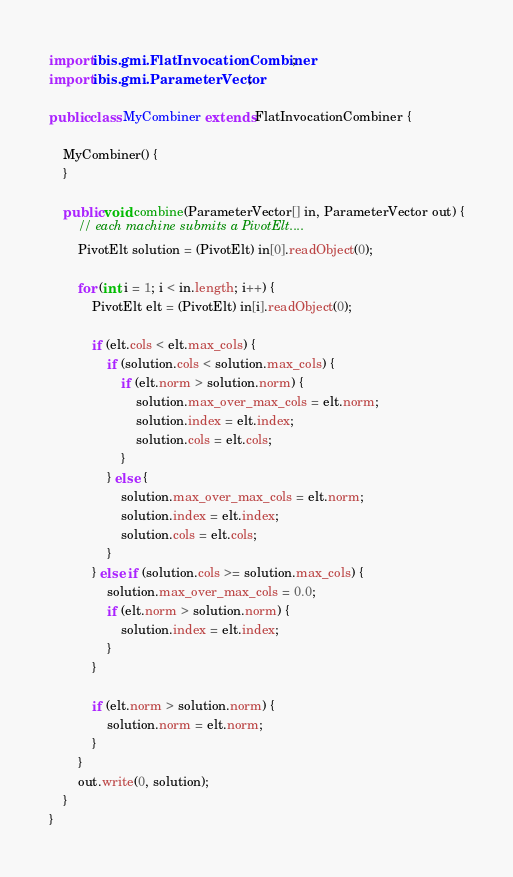Convert code to text. <code><loc_0><loc_0><loc_500><loc_500><_Java_>import ibis.gmi.FlatInvocationCombiner;
import ibis.gmi.ParameterVector;

public class MyCombiner extends FlatInvocationCombiner {

    MyCombiner() {
    }

    public void combine(ParameterVector[] in, ParameterVector out) {
        // each machine submits a PivotElt....
        PivotElt solution = (PivotElt) in[0].readObject(0);

        for (int i = 1; i < in.length; i++) {
            PivotElt elt = (PivotElt) in[i].readObject(0);

            if (elt.cols < elt.max_cols) {
                if (solution.cols < solution.max_cols) {
                    if (elt.norm > solution.norm) {
                        solution.max_over_max_cols = elt.norm;
                        solution.index = elt.index;
                        solution.cols = elt.cols;
                    }
                } else {
                    solution.max_over_max_cols = elt.norm;
                    solution.index = elt.index;
                    solution.cols = elt.cols;
                }
            } else if (solution.cols >= solution.max_cols) {
                solution.max_over_max_cols = 0.0;
                if (elt.norm > solution.norm) {
                    solution.index = elt.index;
                }
            }

            if (elt.norm > solution.norm) {
                solution.norm = elt.norm;
            }
        }
        out.write(0, solution);
    }
}
</code> 